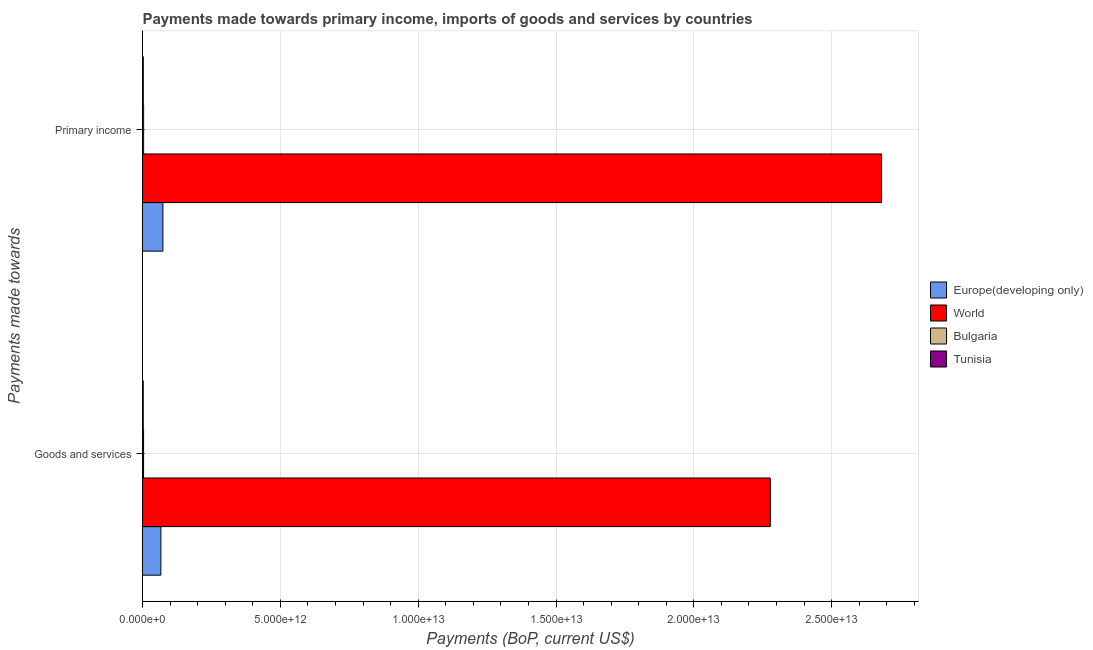How many groups of bars are there?
Offer a terse response. 2. How many bars are there on the 2nd tick from the top?
Your answer should be very brief. 4. What is the label of the 1st group of bars from the top?
Provide a succinct answer. Primary income. What is the payments made towards primary income in World?
Your answer should be very brief. 2.68e+13. Across all countries, what is the maximum payments made towards goods and services?
Your answer should be very brief. 2.28e+13. Across all countries, what is the minimum payments made towards primary income?
Give a very brief answer. 2.87e+1. In which country was the payments made towards primary income maximum?
Offer a very short reply. World. In which country was the payments made towards goods and services minimum?
Keep it short and to the point. Tunisia. What is the total payments made towards goods and services in the graph?
Your answer should be very brief. 2.35e+13. What is the difference between the payments made towards primary income in Europe(developing only) and that in World?
Provide a short and direct response. -2.61e+13. What is the difference between the payments made towards goods and services in World and the payments made towards primary income in Bulgaria?
Your answer should be compact. 2.27e+13. What is the average payments made towards primary income per country?
Keep it short and to the point. 6.90e+12. What is the difference between the payments made towards primary income and payments made towards goods and services in World?
Your answer should be compact. 4.04e+12. In how many countries, is the payments made towards goods and services greater than 16000000000000 US$?
Make the answer very short. 1. What is the ratio of the payments made towards primary income in World to that in Tunisia?
Your answer should be compact. 933.43. What does the 3rd bar from the top in Primary income represents?
Keep it short and to the point. World. What does the 4th bar from the bottom in Goods and services represents?
Your answer should be very brief. Tunisia. How many bars are there?
Make the answer very short. 8. Are all the bars in the graph horizontal?
Make the answer very short. Yes. What is the difference between two consecutive major ticks on the X-axis?
Offer a terse response. 5.00e+12. Are the values on the major ticks of X-axis written in scientific E-notation?
Your answer should be compact. Yes. Does the graph contain any zero values?
Offer a terse response. No. Where does the legend appear in the graph?
Ensure brevity in your answer.  Center right. How many legend labels are there?
Keep it short and to the point. 4. How are the legend labels stacked?
Keep it short and to the point. Vertical. What is the title of the graph?
Your answer should be compact. Payments made towards primary income, imports of goods and services by countries. Does "East Asia (developing only)" appear as one of the legend labels in the graph?
Keep it short and to the point. No. What is the label or title of the X-axis?
Your response must be concise. Payments (BoP, current US$). What is the label or title of the Y-axis?
Provide a succinct answer. Payments made towards. What is the Payments (BoP, current US$) in Europe(developing only) in Goods and services?
Ensure brevity in your answer.  6.66e+11. What is the Payments (BoP, current US$) of World in Goods and services?
Provide a succinct answer. 2.28e+13. What is the Payments (BoP, current US$) in Bulgaria in Goods and services?
Provide a short and direct response. 3.85e+1. What is the Payments (BoP, current US$) of Tunisia in Goods and services?
Give a very brief answer. 2.68e+1. What is the Payments (BoP, current US$) of Europe(developing only) in Primary income?
Provide a short and direct response. 7.40e+11. What is the Payments (BoP, current US$) of World in Primary income?
Provide a succinct answer. 2.68e+13. What is the Payments (BoP, current US$) of Bulgaria in Primary income?
Ensure brevity in your answer.  4.09e+1. What is the Payments (BoP, current US$) in Tunisia in Primary income?
Your answer should be compact. 2.87e+1. Across all Payments made towards, what is the maximum Payments (BoP, current US$) of Europe(developing only)?
Make the answer very short. 7.40e+11. Across all Payments made towards, what is the maximum Payments (BoP, current US$) of World?
Provide a short and direct response. 2.68e+13. Across all Payments made towards, what is the maximum Payments (BoP, current US$) in Bulgaria?
Keep it short and to the point. 4.09e+1. Across all Payments made towards, what is the maximum Payments (BoP, current US$) of Tunisia?
Provide a succinct answer. 2.87e+1. Across all Payments made towards, what is the minimum Payments (BoP, current US$) of Europe(developing only)?
Provide a short and direct response. 6.66e+11. Across all Payments made towards, what is the minimum Payments (BoP, current US$) in World?
Provide a short and direct response. 2.28e+13. Across all Payments made towards, what is the minimum Payments (BoP, current US$) in Bulgaria?
Offer a very short reply. 3.85e+1. Across all Payments made towards, what is the minimum Payments (BoP, current US$) of Tunisia?
Provide a short and direct response. 2.68e+1. What is the total Payments (BoP, current US$) in Europe(developing only) in the graph?
Ensure brevity in your answer.  1.41e+12. What is the total Payments (BoP, current US$) in World in the graph?
Provide a short and direct response. 4.96e+13. What is the total Payments (BoP, current US$) of Bulgaria in the graph?
Offer a terse response. 7.94e+1. What is the total Payments (BoP, current US$) of Tunisia in the graph?
Keep it short and to the point. 5.55e+1. What is the difference between the Payments (BoP, current US$) of Europe(developing only) in Goods and services and that in Primary income?
Make the answer very short. -7.31e+1. What is the difference between the Payments (BoP, current US$) of World in Goods and services and that in Primary income?
Your response must be concise. -4.04e+12. What is the difference between the Payments (BoP, current US$) of Bulgaria in Goods and services and that in Primary income?
Offer a very short reply. -2.39e+09. What is the difference between the Payments (BoP, current US$) in Tunisia in Goods and services and that in Primary income?
Keep it short and to the point. -1.92e+09. What is the difference between the Payments (BoP, current US$) of Europe(developing only) in Goods and services and the Payments (BoP, current US$) of World in Primary income?
Make the answer very short. -2.61e+13. What is the difference between the Payments (BoP, current US$) in Europe(developing only) in Goods and services and the Payments (BoP, current US$) in Bulgaria in Primary income?
Offer a very short reply. 6.26e+11. What is the difference between the Payments (BoP, current US$) of Europe(developing only) in Goods and services and the Payments (BoP, current US$) of Tunisia in Primary income?
Make the answer very short. 6.38e+11. What is the difference between the Payments (BoP, current US$) of World in Goods and services and the Payments (BoP, current US$) of Bulgaria in Primary income?
Your answer should be very brief. 2.27e+13. What is the difference between the Payments (BoP, current US$) of World in Goods and services and the Payments (BoP, current US$) of Tunisia in Primary income?
Keep it short and to the point. 2.27e+13. What is the difference between the Payments (BoP, current US$) in Bulgaria in Goods and services and the Payments (BoP, current US$) in Tunisia in Primary income?
Offer a terse response. 9.80e+09. What is the average Payments (BoP, current US$) in Europe(developing only) per Payments made towards?
Your answer should be compact. 7.03e+11. What is the average Payments (BoP, current US$) of World per Payments made towards?
Provide a succinct answer. 2.48e+13. What is the average Payments (BoP, current US$) of Bulgaria per Payments made towards?
Your response must be concise. 3.97e+1. What is the average Payments (BoP, current US$) in Tunisia per Payments made towards?
Your response must be concise. 2.78e+1. What is the difference between the Payments (BoP, current US$) of Europe(developing only) and Payments (BoP, current US$) of World in Goods and services?
Your answer should be very brief. -2.21e+13. What is the difference between the Payments (BoP, current US$) in Europe(developing only) and Payments (BoP, current US$) in Bulgaria in Goods and services?
Offer a very short reply. 6.28e+11. What is the difference between the Payments (BoP, current US$) of Europe(developing only) and Payments (BoP, current US$) of Tunisia in Goods and services?
Offer a terse response. 6.40e+11. What is the difference between the Payments (BoP, current US$) in World and Payments (BoP, current US$) in Bulgaria in Goods and services?
Keep it short and to the point. 2.27e+13. What is the difference between the Payments (BoP, current US$) in World and Payments (BoP, current US$) in Tunisia in Goods and services?
Offer a very short reply. 2.27e+13. What is the difference between the Payments (BoP, current US$) of Bulgaria and Payments (BoP, current US$) of Tunisia in Goods and services?
Keep it short and to the point. 1.17e+1. What is the difference between the Payments (BoP, current US$) in Europe(developing only) and Payments (BoP, current US$) in World in Primary income?
Give a very brief answer. -2.61e+13. What is the difference between the Payments (BoP, current US$) of Europe(developing only) and Payments (BoP, current US$) of Bulgaria in Primary income?
Make the answer very short. 6.99e+11. What is the difference between the Payments (BoP, current US$) of Europe(developing only) and Payments (BoP, current US$) of Tunisia in Primary income?
Give a very brief answer. 7.11e+11. What is the difference between the Payments (BoP, current US$) in World and Payments (BoP, current US$) in Bulgaria in Primary income?
Your answer should be compact. 2.68e+13. What is the difference between the Payments (BoP, current US$) of World and Payments (BoP, current US$) of Tunisia in Primary income?
Your answer should be compact. 2.68e+13. What is the difference between the Payments (BoP, current US$) in Bulgaria and Payments (BoP, current US$) in Tunisia in Primary income?
Your response must be concise. 1.22e+1. What is the ratio of the Payments (BoP, current US$) of Europe(developing only) in Goods and services to that in Primary income?
Give a very brief answer. 0.9. What is the ratio of the Payments (BoP, current US$) of World in Goods and services to that in Primary income?
Ensure brevity in your answer.  0.85. What is the ratio of the Payments (BoP, current US$) in Bulgaria in Goods and services to that in Primary income?
Offer a very short reply. 0.94. What is the ratio of the Payments (BoP, current US$) in Tunisia in Goods and services to that in Primary income?
Give a very brief answer. 0.93. What is the difference between the highest and the second highest Payments (BoP, current US$) of Europe(developing only)?
Provide a short and direct response. 7.31e+1. What is the difference between the highest and the second highest Payments (BoP, current US$) of World?
Offer a terse response. 4.04e+12. What is the difference between the highest and the second highest Payments (BoP, current US$) in Bulgaria?
Offer a terse response. 2.39e+09. What is the difference between the highest and the second highest Payments (BoP, current US$) in Tunisia?
Your answer should be compact. 1.92e+09. What is the difference between the highest and the lowest Payments (BoP, current US$) of Europe(developing only)?
Your answer should be very brief. 7.31e+1. What is the difference between the highest and the lowest Payments (BoP, current US$) of World?
Your answer should be compact. 4.04e+12. What is the difference between the highest and the lowest Payments (BoP, current US$) of Bulgaria?
Your response must be concise. 2.39e+09. What is the difference between the highest and the lowest Payments (BoP, current US$) of Tunisia?
Your answer should be very brief. 1.92e+09. 